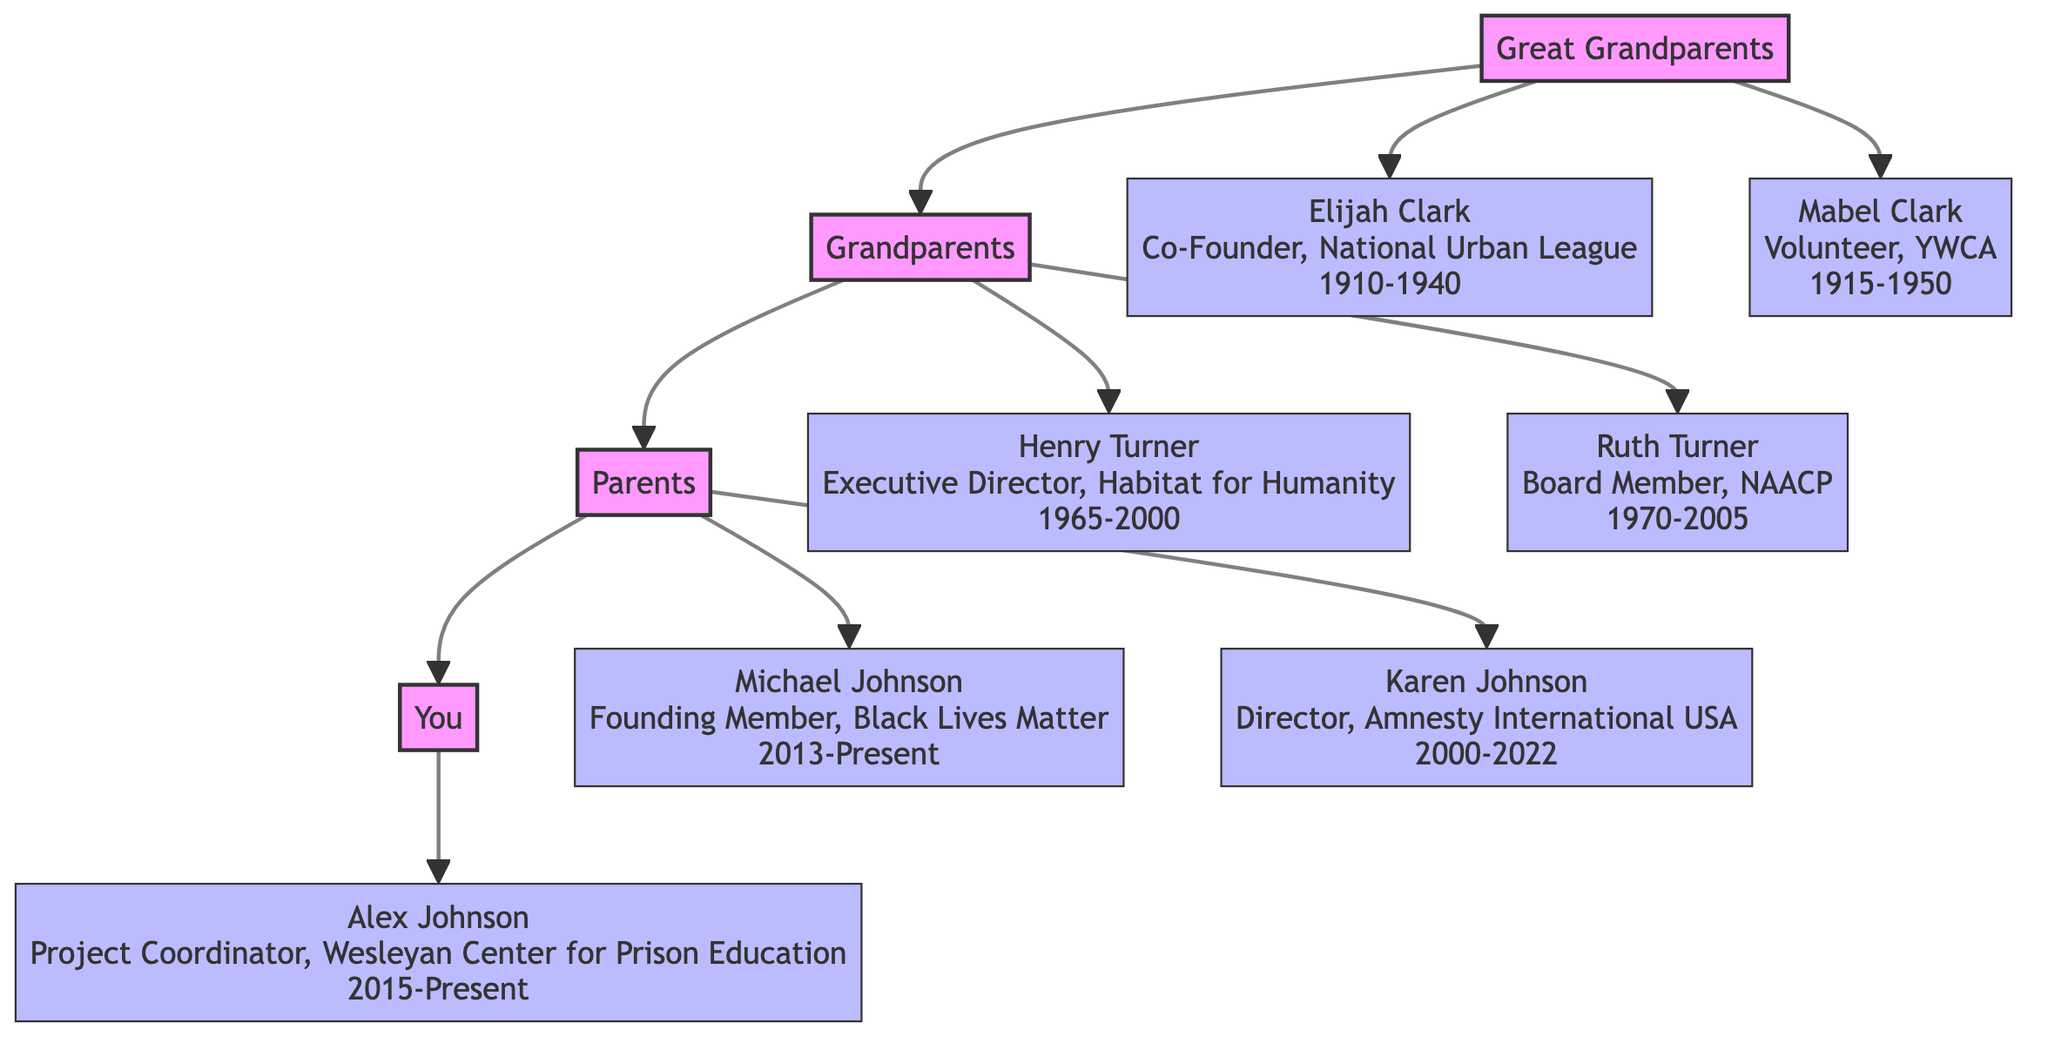What is the name of the Great Grandparent who co-founded the National Urban League? The diagram indicates that the Great Grandparent who co-founded the National Urban League is Elijah Clark. This can be found by locating the "Great Grandparents" generation and then looking for the member associated with that organization.
Answer: Elijah Clark How many generations are represented in the diagram? The diagram consists of four distinct generations: Great Grandparents, Grandparents, Parents, and You. Counting each of these levels gives a total of four generations.
Answer: 4 Which member was active from 2000 to 2022? In the "Parents" generation, the member who served as the Director of Amnesty International USA and was active from 2000 to 2022 is Karen Johnson. This information can be gathered by looking at the timeline presented next to her name.
Answer: Karen Johnson Who is the member linked to the Black Lives Matter movement? Michael Johnson, listed in the "Parents" generation as a Founding Member of Black Lives Matter, identifies him as the relevant member. This can be verified by checking the "Parents" section for his involvement in that organization.
Answer: Michael Johnson Which member was involved with NAACP and how long did they serve? In the "Grandparents" generation, Ruth Turner was a Board Member for the NAACP, serving from 1970 to 2005. This combination of membership and timeline details can be found in her description under the "Grandparents".
Answer: Ruth Turner, 1970-2005 What is the relationship between Alex Johnson and Elijah Clark? Alex Johnson is the great-grandchild of Elijah Clark. By following the family tree structure, we see that "You" (Alex Johnson) are linked to "Parents", who in turn are linked to "Grandparents", which goes back to "Great Grandparents" where Elijah Clark is found.
Answer: Great-Grandchild How many members from the Grandparents generation are listed? The diagram includes two members from the Grandparents generation: Henry Turner and Ruth Turner. Counting these members confirms there are two present in the "Grandparents" section.
Answer: 2 Who has the most recent active years shown in the diagram? The most recent active years in the diagram are associated with Michael Johnson and Alex Johnson, both being listed as "Present" indicating ongoing involvement. However, Alex Johnson is the latest member listed directly, so he reflects this most recent activity.
Answer: Alex Johnson What role did Mabel Clark hold in the YWCA? Mabel Clark is identified as a Volunteer at the YWCA, according to the description in the "Great Grandparents" section of the diagram. This can be accessed by looking for her involvement description next to her name.
Answer: Volunteer, YWCA 